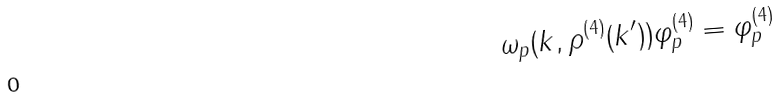Convert formula to latex. <formula><loc_0><loc_0><loc_500><loc_500>\omega _ { p } ( k , \rho ^ { ( 4 ) } ( k ^ { \prime } ) ) \varphi _ { p } ^ { ( 4 ) } = \varphi _ { p } ^ { ( 4 ) }</formula> 